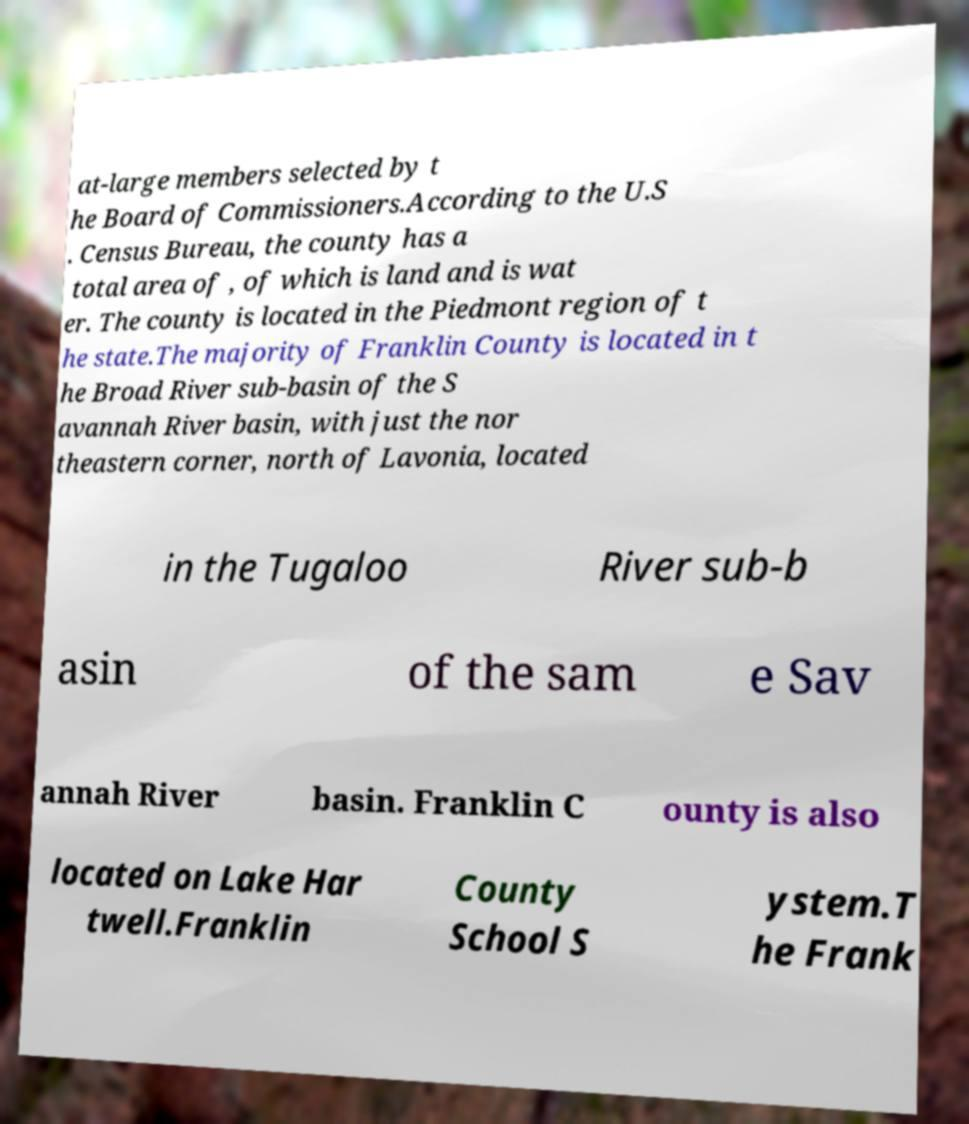Can you read and provide the text displayed in the image?This photo seems to have some interesting text. Can you extract and type it out for me? at-large members selected by t he Board of Commissioners.According to the U.S . Census Bureau, the county has a total area of , of which is land and is wat er. The county is located in the Piedmont region of t he state.The majority of Franklin County is located in t he Broad River sub-basin of the S avannah River basin, with just the nor theastern corner, north of Lavonia, located in the Tugaloo River sub-b asin of the sam e Sav annah River basin. Franklin C ounty is also located on Lake Har twell.Franklin County School S ystem.T he Frank 